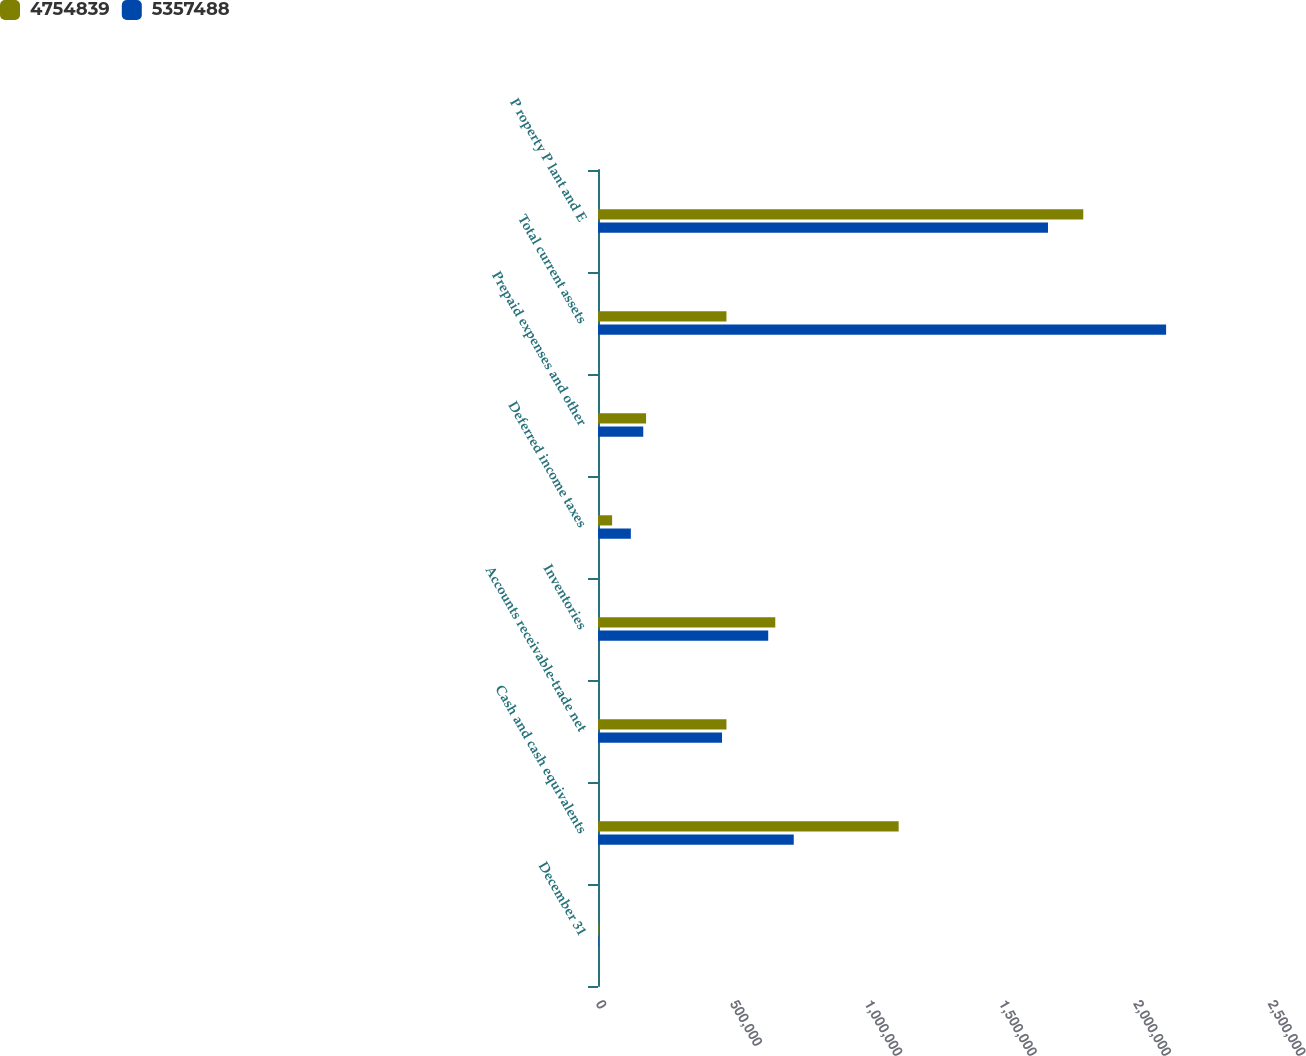Convert chart. <chart><loc_0><loc_0><loc_500><loc_500><stacked_bar_chart><ecel><fcel>December 31<fcel>Cash and cash equivalents<fcel>Accounts receivable-trade net<fcel>Inventories<fcel>Deferred income taxes<fcel>Prepaid expenses and other<fcel>Total current assets<fcel>P roperty P lant and E<nl><fcel>4.75484e+06<fcel>2013<fcel>1.11851e+06<fcel>477912<fcel>659541<fcel>52511<fcel>178862<fcel>477912<fcel>1.80534e+06<nl><fcel>5.35749e+06<fcel>2012<fcel>728272<fcel>461383<fcel>633262<fcel>122224<fcel>168344<fcel>2.11348e+06<fcel>1.67407e+06<nl></chart> 